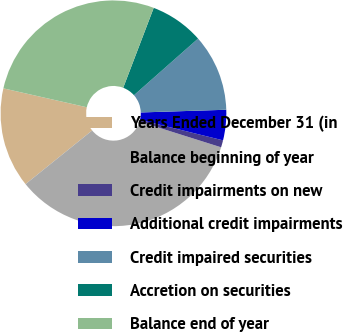<chart> <loc_0><loc_0><loc_500><loc_500><pie_chart><fcel>Years Ended December 31 (in<fcel>Balance beginning of year<fcel>Credit impairments on new<fcel>Additional credit impairments<fcel>Credit impaired securities<fcel>Accretion on securities<fcel>Balance end of year<nl><fcel>14.34%<fcel>34.33%<fcel>1.02%<fcel>4.35%<fcel>11.01%<fcel>7.68%<fcel>27.25%<nl></chart> 